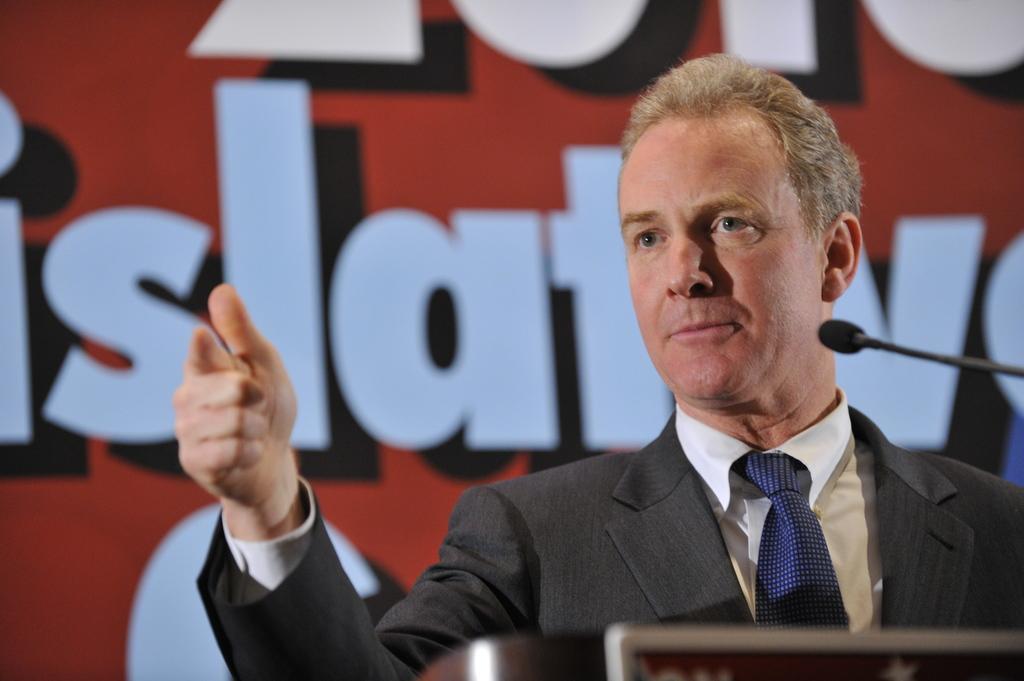Please provide a concise description of this image. In this image on the right side there is a person visible, in front of podium, there is a mike on the right side, in the background may be there is the wall, on which there is a text. 